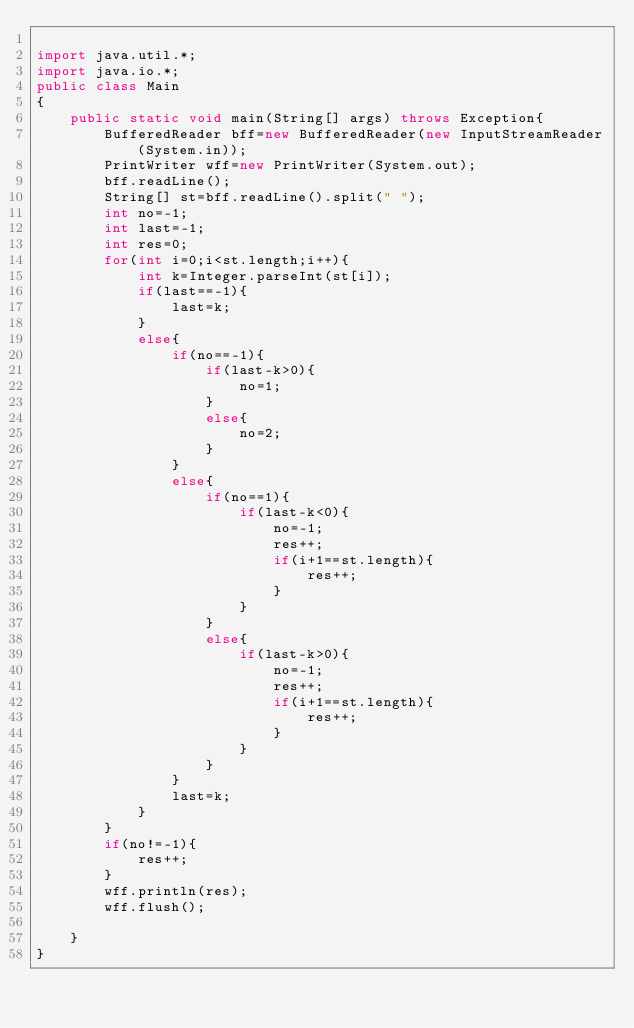Convert code to text. <code><loc_0><loc_0><loc_500><loc_500><_Java_>
import java.util.*;
import java.io.*;
public class Main
{
    public static void main(String[] args) throws Exception{
        BufferedReader bff=new BufferedReader(new InputStreamReader(System.in));
        PrintWriter wff=new PrintWriter(System.out);
        bff.readLine();
        String[] st=bff.readLine().split(" ");
        int no=-1;
        int last=-1;
        int res=0;
        for(int i=0;i<st.length;i++){
            int k=Integer.parseInt(st[i]);
            if(last==-1){
                last=k;
            }
            else{
                if(no==-1){
                    if(last-k>0){
                        no=1;
                    }
                    else{
                        no=2;
                    }
                }
                else{
                    if(no==1){
                        if(last-k<0){
                            no=-1;
                            res++;
                            if(i+1==st.length){
                                res++;
                            }
                        }
                    }
                    else{
                        if(last-k>0){
                            no=-1;
                            res++;
                            if(i+1==st.length){
                                res++;
                            }
                        }
                    }
                }
                last=k;
            }
        }
        if(no!=-1){
            res++;
        }
        wff.println(res);
        wff.flush();
        
    }
}
</code> 